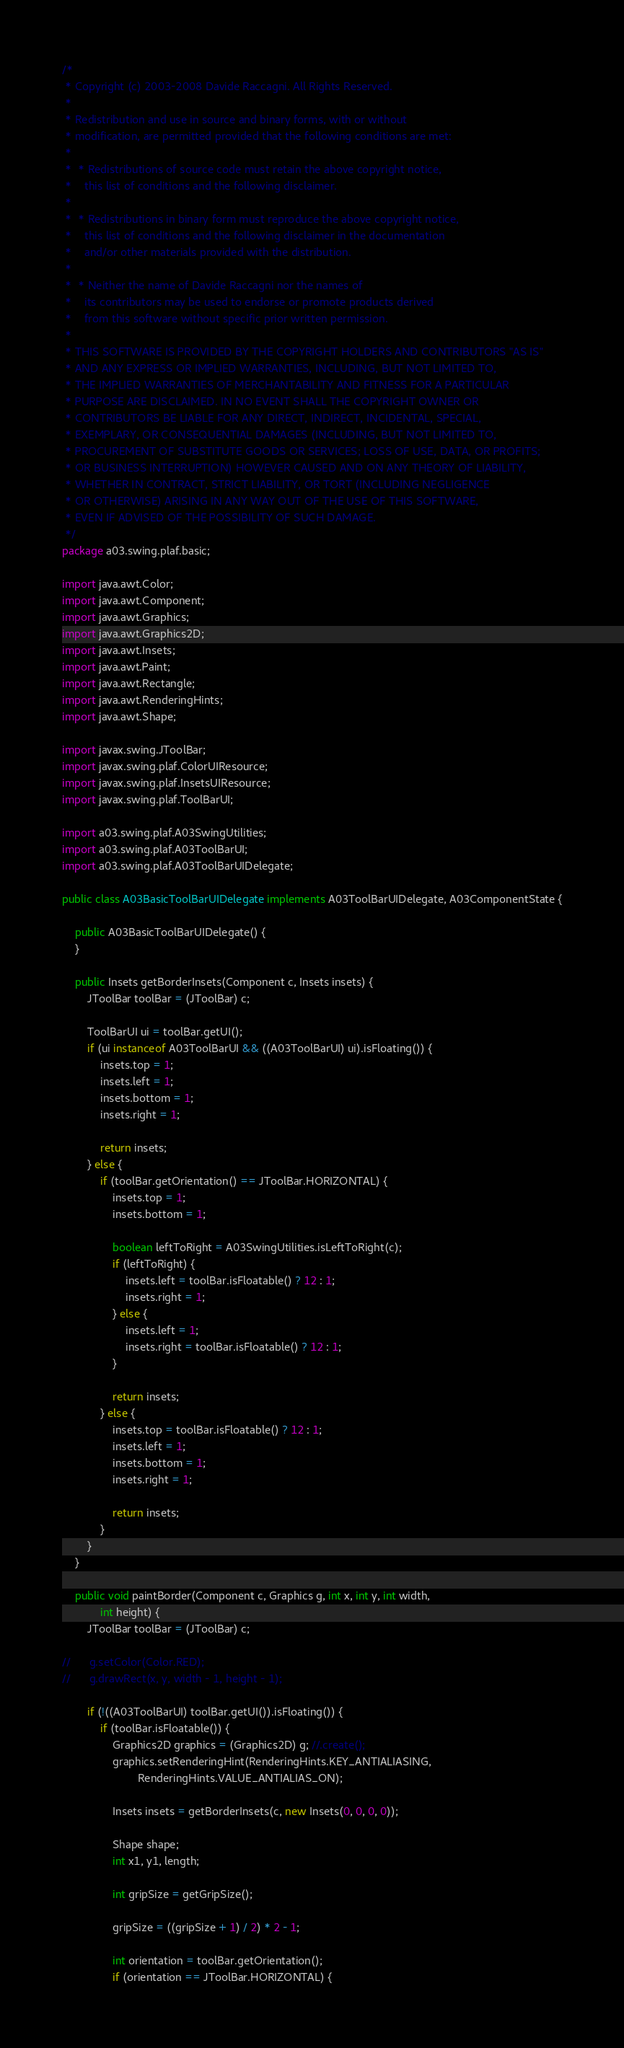<code> <loc_0><loc_0><loc_500><loc_500><_Java_>/*
 * Copyright (c) 2003-2008 Davide Raccagni. All Rights Reserved.
 *
 * Redistribution and use in source and binary forms, with or without 
 * modification, are permitted provided that the following conditions are met:
 * 
 *  * Redistributions of source code must retain the above copyright notice, 
 *    this list of conditions and the following disclaimer. 
 *     
 *  * Redistributions in binary form must reproduce the above copyright notice, 
 *    this list of conditions and the following disclaimer in the documentation 
 *    and/or other materials provided with the distribution. 
 *     
 *  * Neither the name of Davide Raccagni nor the names of 
 *    its contributors may be used to endorse or promote products derived 
 *    from this software without specific prior written permission. 
 *     
 * THIS SOFTWARE IS PROVIDED BY THE COPYRIGHT HOLDERS AND CONTRIBUTORS "AS IS" 
 * AND ANY EXPRESS OR IMPLIED WARRANTIES, INCLUDING, BUT NOT LIMITED TO, 
 * THE IMPLIED WARRANTIES OF MERCHANTABILITY AND FITNESS FOR A PARTICULAR 
 * PURPOSE ARE DISCLAIMED. IN NO EVENT SHALL THE COPYRIGHT OWNER OR 
 * CONTRIBUTORS BE LIABLE FOR ANY DIRECT, INDIRECT, INCIDENTAL, SPECIAL, 
 * EXEMPLARY, OR CONSEQUENTIAL DAMAGES (INCLUDING, BUT NOT LIMITED TO, 
 * PROCUREMENT OF SUBSTITUTE GOODS OR SERVICES; LOSS OF USE, DATA, OR PROFITS; 
 * OR BUSINESS INTERRUPTION) HOWEVER CAUSED AND ON ANY THEORY OF LIABILITY, 
 * WHETHER IN CONTRACT, STRICT LIABILITY, OR TORT (INCLUDING NEGLIGENCE 
 * OR OTHERWISE) ARISING IN ANY WAY OUT OF THE USE OF THIS SOFTWARE, 
 * EVEN IF ADVISED OF THE POSSIBILITY OF SUCH DAMAGE. 
 */
package a03.swing.plaf.basic;

import java.awt.Color;
import java.awt.Component;
import java.awt.Graphics;
import java.awt.Graphics2D;
import java.awt.Insets;
import java.awt.Paint;
import java.awt.Rectangle;
import java.awt.RenderingHints;
import java.awt.Shape;

import javax.swing.JToolBar;
import javax.swing.plaf.ColorUIResource;
import javax.swing.plaf.InsetsUIResource;
import javax.swing.plaf.ToolBarUI;

import a03.swing.plaf.A03SwingUtilities;
import a03.swing.plaf.A03ToolBarUI;
import a03.swing.plaf.A03ToolBarUIDelegate;

public class A03BasicToolBarUIDelegate implements A03ToolBarUIDelegate, A03ComponentState {

	public A03BasicToolBarUIDelegate() {
	}
	
	public Insets getBorderInsets(Component c, Insets insets) {
		JToolBar toolBar = (JToolBar) c;
		
		ToolBarUI ui = toolBar.getUI();
		if (ui instanceof A03ToolBarUI && ((A03ToolBarUI) ui).isFloating()) {
			insets.top = 1;
			insets.left = 1;
			insets.bottom = 1;
			insets.right = 1;

			return insets;				
		} else {
			if (toolBar.getOrientation() == JToolBar.HORIZONTAL) {
				insets.top = 1;
				insets.bottom = 1;
				
				boolean leftToRight = A03SwingUtilities.isLeftToRight(c);
				if (leftToRight) {
					insets.left = toolBar.isFloatable() ? 12 : 1;
					insets.right = 1;
				} else {
					insets.left = 1;
					insets.right = toolBar.isFloatable() ? 12 : 1;					
				}
	
				return insets;				
			} else {
				insets.top = toolBar.isFloatable() ? 12 : 1;
				insets.left = 1;
				insets.bottom = 1;
				insets.right = 1;
	
				return insets;
			}
		}
	}

	public void paintBorder(Component c, Graphics g, int x, int y, int width,
			int height) {
		JToolBar toolBar = (JToolBar) c;

//		g.setColor(Color.RED);
//		g.drawRect(x, y, width - 1, height - 1);
		
		if (!((A03ToolBarUI) toolBar.getUI()).isFloating()) {
			if (toolBar.isFloatable()) {
				Graphics2D graphics = (Graphics2D) g; //.create();
				graphics.setRenderingHint(RenderingHints.KEY_ANTIALIASING,
						RenderingHints.VALUE_ANTIALIAS_ON);
		
				Insets insets = getBorderInsets(c, new Insets(0, 0, 0, 0));
				
				Shape shape;
				int x1, y1, length;
				
				int gripSize = getGripSize();
				
				gripSize = ((gripSize + 1) / 2) * 2 - 1;
				
				int orientation = toolBar.getOrientation();
				if (orientation == JToolBar.HORIZONTAL) {</code> 